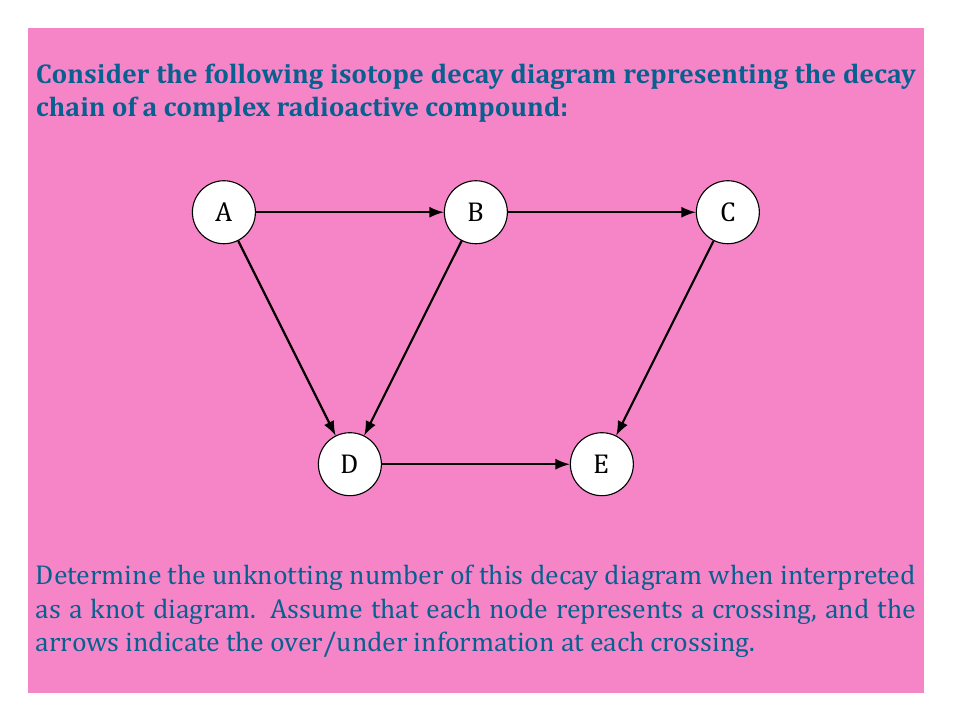Give your solution to this math problem. To solve this problem, we need to follow these steps:

1) First, we need to interpret the decay diagram as a knot diagram. Each node (A, B, C, D, E) represents a crossing, and the arrows indicate the path of the knot.

2) The unknotting number is defined as the minimum number of crossing changes needed to transform the knot into the unknot (trivial knot).

3) Let's analyze each crossing:
   - Crossing A: This is part of a loop from A to D to B and back to A. We can remove this loop without changing any crossings.
   - Crossing B: This is connected to A, C, and D. After removing the A-D-B loop, this becomes a simple crossing.
   - Crossing C: This is connected to B and E. It forms another simple crossing.
   - Crossing D: After removing the A-D-B loop, this crossing is eliminated.
   - Crossing E: This is connected to C and forms the end of the knot.

4) After these simplifications, we're left with essentially two crossings: B and C.

5) To unknot this configuration, we need to change one of these crossings. Changing either B or C will result in the unknot.

Therefore, the unknotting number for this diagram is 1. We only need to change one crossing to transform this knot into the unknot.

This problem relates to the nuclear chemist persona by representing complex decay chains as knot-like structures, providing a novel way to visualize and analyze radioactive compound decay pathways.
Answer: 1 